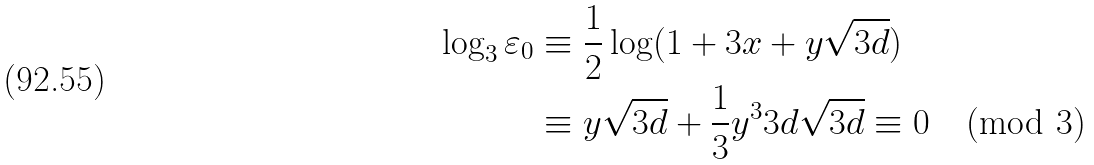Convert formula to latex. <formula><loc_0><loc_0><loc_500><loc_500>\log _ { 3 } \varepsilon _ { 0 } & \equiv \frac { 1 } { 2 } \log ( 1 + 3 x + y \sqrt { 3 d } ) \\ & \equiv y \sqrt { 3 d } + \frac { 1 } { 3 } y ^ { 3 } 3 d \sqrt { 3 d } \equiv 0 \pmod { 3 }</formula> 